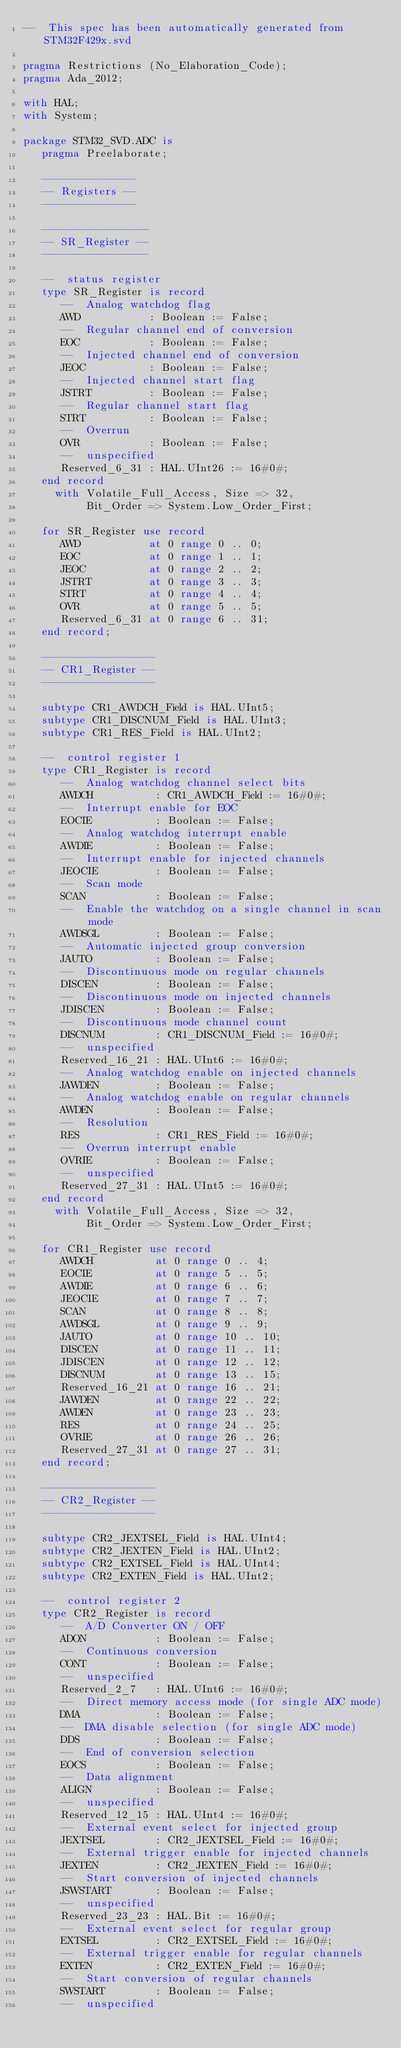Convert code to text. <code><loc_0><loc_0><loc_500><loc_500><_Ada_>--  This spec has been automatically generated from STM32F429x.svd

pragma Restrictions (No_Elaboration_Code);
pragma Ada_2012;

with HAL;
with System;

package STM32_SVD.ADC is
   pragma Preelaborate;

   ---------------
   -- Registers --
   ---------------

   -----------------
   -- SR_Register --
   -----------------

   --  status register
   type SR_Register is record
      --  Analog watchdog flag
      AWD           : Boolean := False;
      --  Regular channel end of conversion
      EOC           : Boolean := False;
      --  Injected channel end of conversion
      JEOC          : Boolean := False;
      --  Injected channel start flag
      JSTRT         : Boolean := False;
      --  Regular channel start flag
      STRT          : Boolean := False;
      --  Overrun
      OVR           : Boolean := False;
      --  unspecified
      Reserved_6_31 : HAL.UInt26 := 16#0#;
   end record
     with Volatile_Full_Access, Size => 32,
          Bit_Order => System.Low_Order_First;

   for SR_Register use record
      AWD           at 0 range 0 .. 0;
      EOC           at 0 range 1 .. 1;
      JEOC          at 0 range 2 .. 2;
      JSTRT         at 0 range 3 .. 3;
      STRT          at 0 range 4 .. 4;
      OVR           at 0 range 5 .. 5;
      Reserved_6_31 at 0 range 6 .. 31;
   end record;

   ------------------
   -- CR1_Register --
   ------------------

   subtype CR1_AWDCH_Field is HAL.UInt5;
   subtype CR1_DISCNUM_Field is HAL.UInt3;
   subtype CR1_RES_Field is HAL.UInt2;

   --  control register 1
   type CR1_Register is record
      --  Analog watchdog channel select bits
      AWDCH          : CR1_AWDCH_Field := 16#0#;
      --  Interrupt enable for EOC
      EOCIE          : Boolean := False;
      --  Analog watchdog interrupt enable
      AWDIE          : Boolean := False;
      --  Interrupt enable for injected channels
      JEOCIE         : Boolean := False;
      --  Scan mode
      SCAN           : Boolean := False;
      --  Enable the watchdog on a single channel in scan mode
      AWDSGL         : Boolean := False;
      --  Automatic injected group conversion
      JAUTO          : Boolean := False;
      --  Discontinuous mode on regular channels
      DISCEN         : Boolean := False;
      --  Discontinuous mode on injected channels
      JDISCEN        : Boolean := False;
      --  Discontinuous mode channel count
      DISCNUM        : CR1_DISCNUM_Field := 16#0#;
      --  unspecified
      Reserved_16_21 : HAL.UInt6 := 16#0#;
      --  Analog watchdog enable on injected channels
      JAWDEN         : Boolean := False;
      --  Analog watchdog enable on regular channels
      AWDEN          : Boolean := False;
      --  Resolution
      RES            : CR1_RES_Field := 16#0#;
      --  Overrun interrupt enable
      OVRIE          : Boolean := False;
      --  unspecified
      Reserved_27_31 : HAL.UInt5 := 16#0#;
   end record
     with Volatile_Full_Access, Size => 32,
          Bit_Order => System.Low_Order_First;

   for CR1_Register use record
      AWDCH          at 0 range 0 .. 4;
      EOCIE          at 0 range 5 .. 5;
      AWDIE          at 0 range 6 .. 6;
      JEOCIE         at 0 range 7 .. 7;
      SCAN           at 0 range 8 .. 8;
      AWDSGL         at 0 range 9 .. 9;
      JAUTO          at 0 range 10 .. 10;
      DISCEN         at 0 range 11 .. 11;
      JDISCEN        at 0 range 12 .. 12;
      DISCNUM        at 0 range 13 .. 15;
      Reserved_16_21 at 0 range 16 .. 21;
      JAWDEN         at 0 range 22 .. 22;
      AWDEN          at 0 range 23 .. 23;
      RES            at 0 range 24 .. 25;
      OVRIE          at 0 range 26 .. 26;
      Reserved_27_31 at 0 range 27 .. 31;
   end record;

   ------------------
   -- CR2_Register --
   ------------------

   subtype CR2_JEXTSEL_Field is HAL.UInt4;
   subtype CR2_JEXTEN_Field is HAL.UInt2;
   subtype CR2_EXTSEL_Field is HAL.UInt4;
   subtype CR2_EXTEN_Field is HAL.UInt2;

   --  control register 2
   type CR2_Register is record
      --  A/D Converter ON / OFF
      ADON           : Boolean := False;
      --  Continuous conversion
      CONT           : Boolean := False;
      --  unspecified
      Reserved_2_7   : HAL.UInt6 := 16#0#;
      --  Direct memory access mode (for single ADC mode)
      DMA            : Boolean := False;
      --  DMA disable selection (for single ADC mode)
      DDS            : Boolean := False;
      --  End of conversion selection
      EOCS           : Boolean := False;
      --  Data alignment
      ALIGN          : Boolean := False;
      --  unspecified
      Reserved_12_15 : HAL.UInt4 := 16#0#;
      --  External event select for injected group
      JEXTSEL        : CR2_JEXTSEL_Field := 16#0#;
      --  External trigger enable for injected channels
      JEXTEN         : CR2_JEXTEN_Field := 16#0#;
      --  Start conversion of injected channels
      JSWSTART       : Boolean := False;
      --  unspecified
      Reserved_23_23 : HAL.Bit := 16#0#;
      --  External event select for regular group
      EXTSEL         : CR2_EXTSEL_Field := 16#0#;
      --  External trigger enable for regular channels
      EXTEN          : CR2_EXTEN_Field := 16#0#;
      --  Start conversion of regular channels
      SWSTART        : Boolean := False;
      --  unspecified</code> 